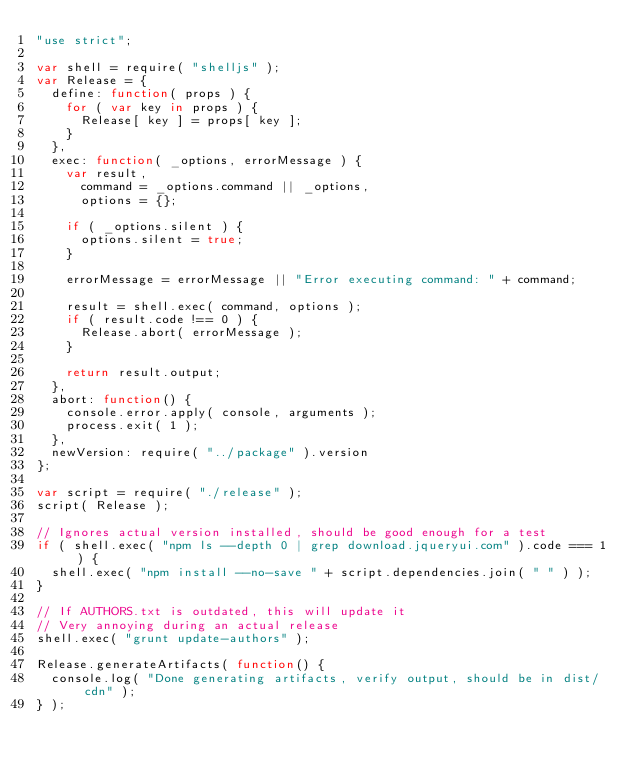<code> <loc_0><loc_0><loc_500><loc_500><_JavaScript_>"use strict";

var shell = require( "shelljs" );
var Release = {
	define: function( props ) {
		for ( var key in props ) {
			Release[ key ] = props[ key ];
		}
	},
	exec: function( _options, errorMessage ) {
		var result,
			command = _options.command || _options,
			options = {};

		if ( _options.silent ) {
			options.silent = true;
		}

		errorMessage = errorMessage || "Error executing command: " + command;

		result = shell.exec( command, options );
		if ( result.code !== 0 ) {
			Release.abort( errorMessage );
		}

		return result.output;
	},
	abort: function() {
		console.error.apply( console, arguments );
		process.exit( 1 );
	},
	newVersion: require( "../package" ).version
};

var script = require( "./release" );
script( Release );

// Ignores actual version installed, should be good enough for a test
if ( shell.exec( "npm ls --depth 0 | grep download.jqueryui.com" ).code === 1 ) {
	shell.exec( "npm install --no-save " + script.dependencies.join( " " ) );
}

// If AUTHORS.txt is outdated, this will update it
// Very annoying during an actual release
shell.exec( "grunt update-authors" );

Release.generateArtifacts( function() {
	console.log( "Done generating artifacts, verify output, should be in dist/cdn" );
} );
</code> 